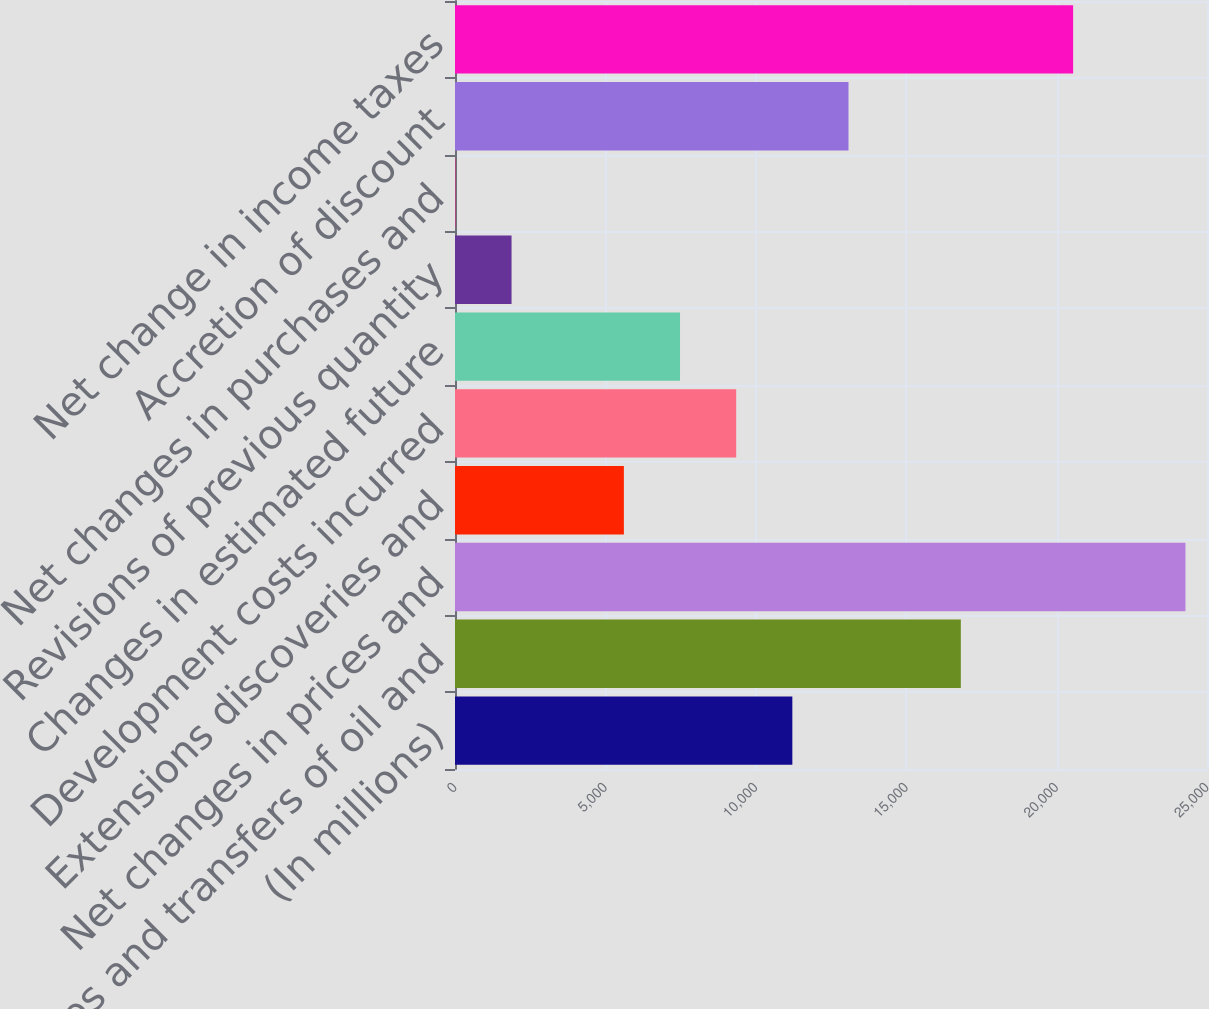<chart> <loc_0><loc_0><loc_500><loc_500><bar_chart><fcel>(In millions)<fcel>Sales and transfers of oil and<fcel>Net changes in prices and<fcel>Extensions discoveries and<fcel>Development costs incurred<fcel>Changes in estimated future<fcel>Revisions of previous quantity<fcel>Net changes in purchases and<fcel>Accretion of discount<fcel>Net change in income taxes<nl><fcel>11215<fcel>16816<fcel>24284<fcel>5614<fcel>9348<fcel>7481<fcel>1880<fcel>13<fcel>13082<fcel>20550<nl></chart> 